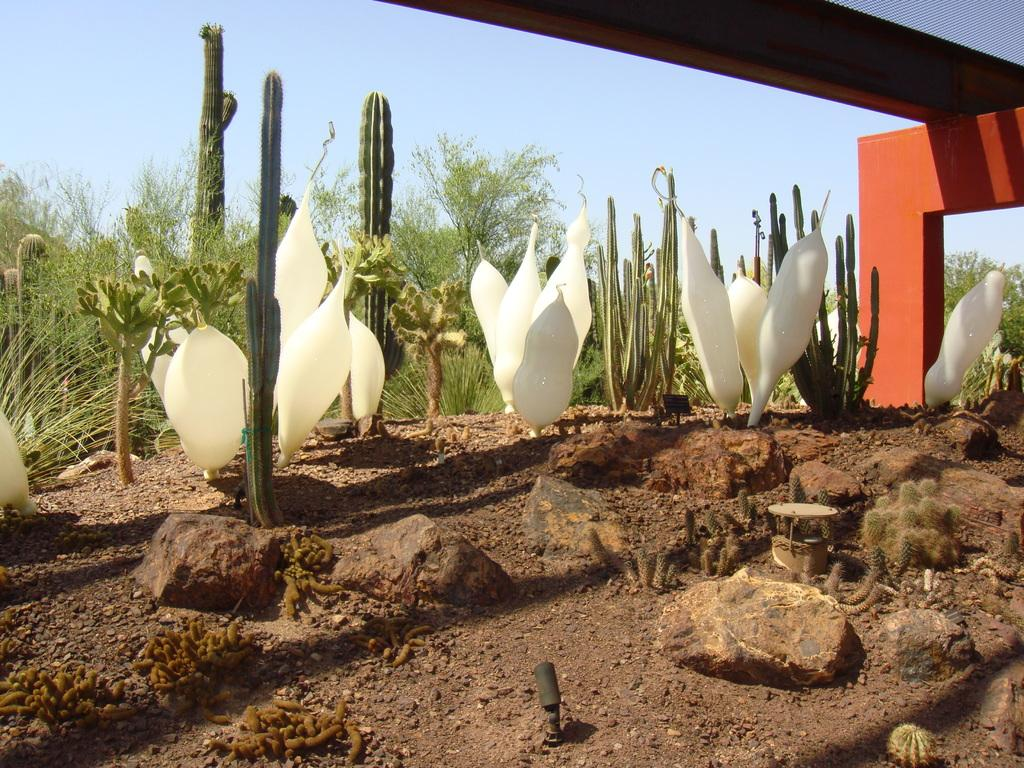What type of plants can be seen in the image? There are cactus plants and other plants in the image. What is located at the bottom of the image? There are stones at the bottom of the image. What can be seen in the background of the image? There are trees in the background of the image. What is visible at the top of the image? The sky is visible at the top of the image. What type of print can be seen on the bikes in the image? There are no bikes present in the image, so there is no print to observe. 